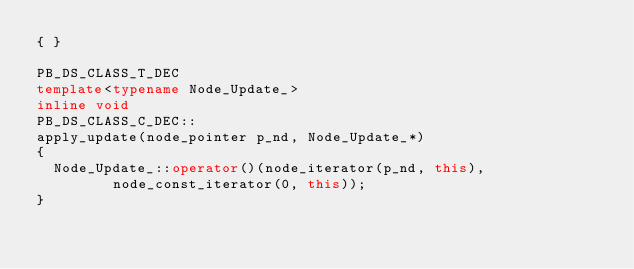Convert code to text. <code><loc_0><loc_0><loc_500><loc_500><_C++_>{ }

PB_DS_CLASS_T_DEC
template<typename Node_Update_>
inline void
PB_DS_CLASS_C_DEC::
apply_update(node_pointer p_nd, Node_Update_*)
{
  Node_Update_::operator()(node_iterator(p_nd, this),
			   node_const_iterator(0, this));
}
</code> 